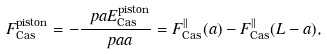<formula> <loc_0><loc_0><loc_500><loc_500>F _ { \text {Cas} } ^ { \text {piston} } = - \frac { \ p a E _ { \text {Cas} } ^ { \text {piston} } } { \ p a a } = F _ { \text {Cas} } ^ { \| } ( a ) - F _ { \text {Cas} } ^ { \| } ( L - a ) ,</formula> 